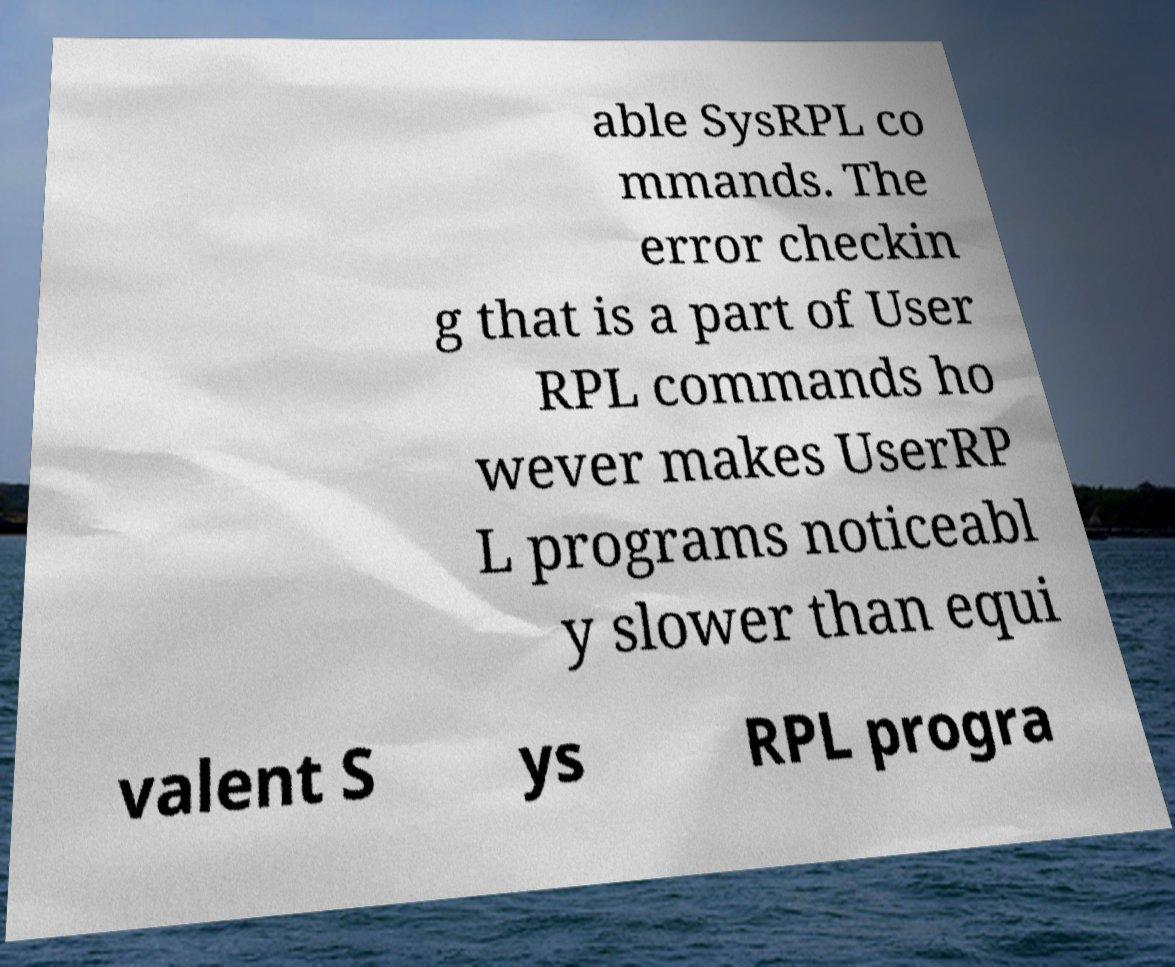Please identify and transcribe the text found in this image. able SysRPL co mmands. The error checkin g that is a part of User RPL commands ho wever makes UserRP L programs noticeabl y slower than equi valent S ys RPL progra 